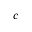Convert formula to latex. <formula><loc_0><loc_0><loc_500><loc_500>c</formula> 